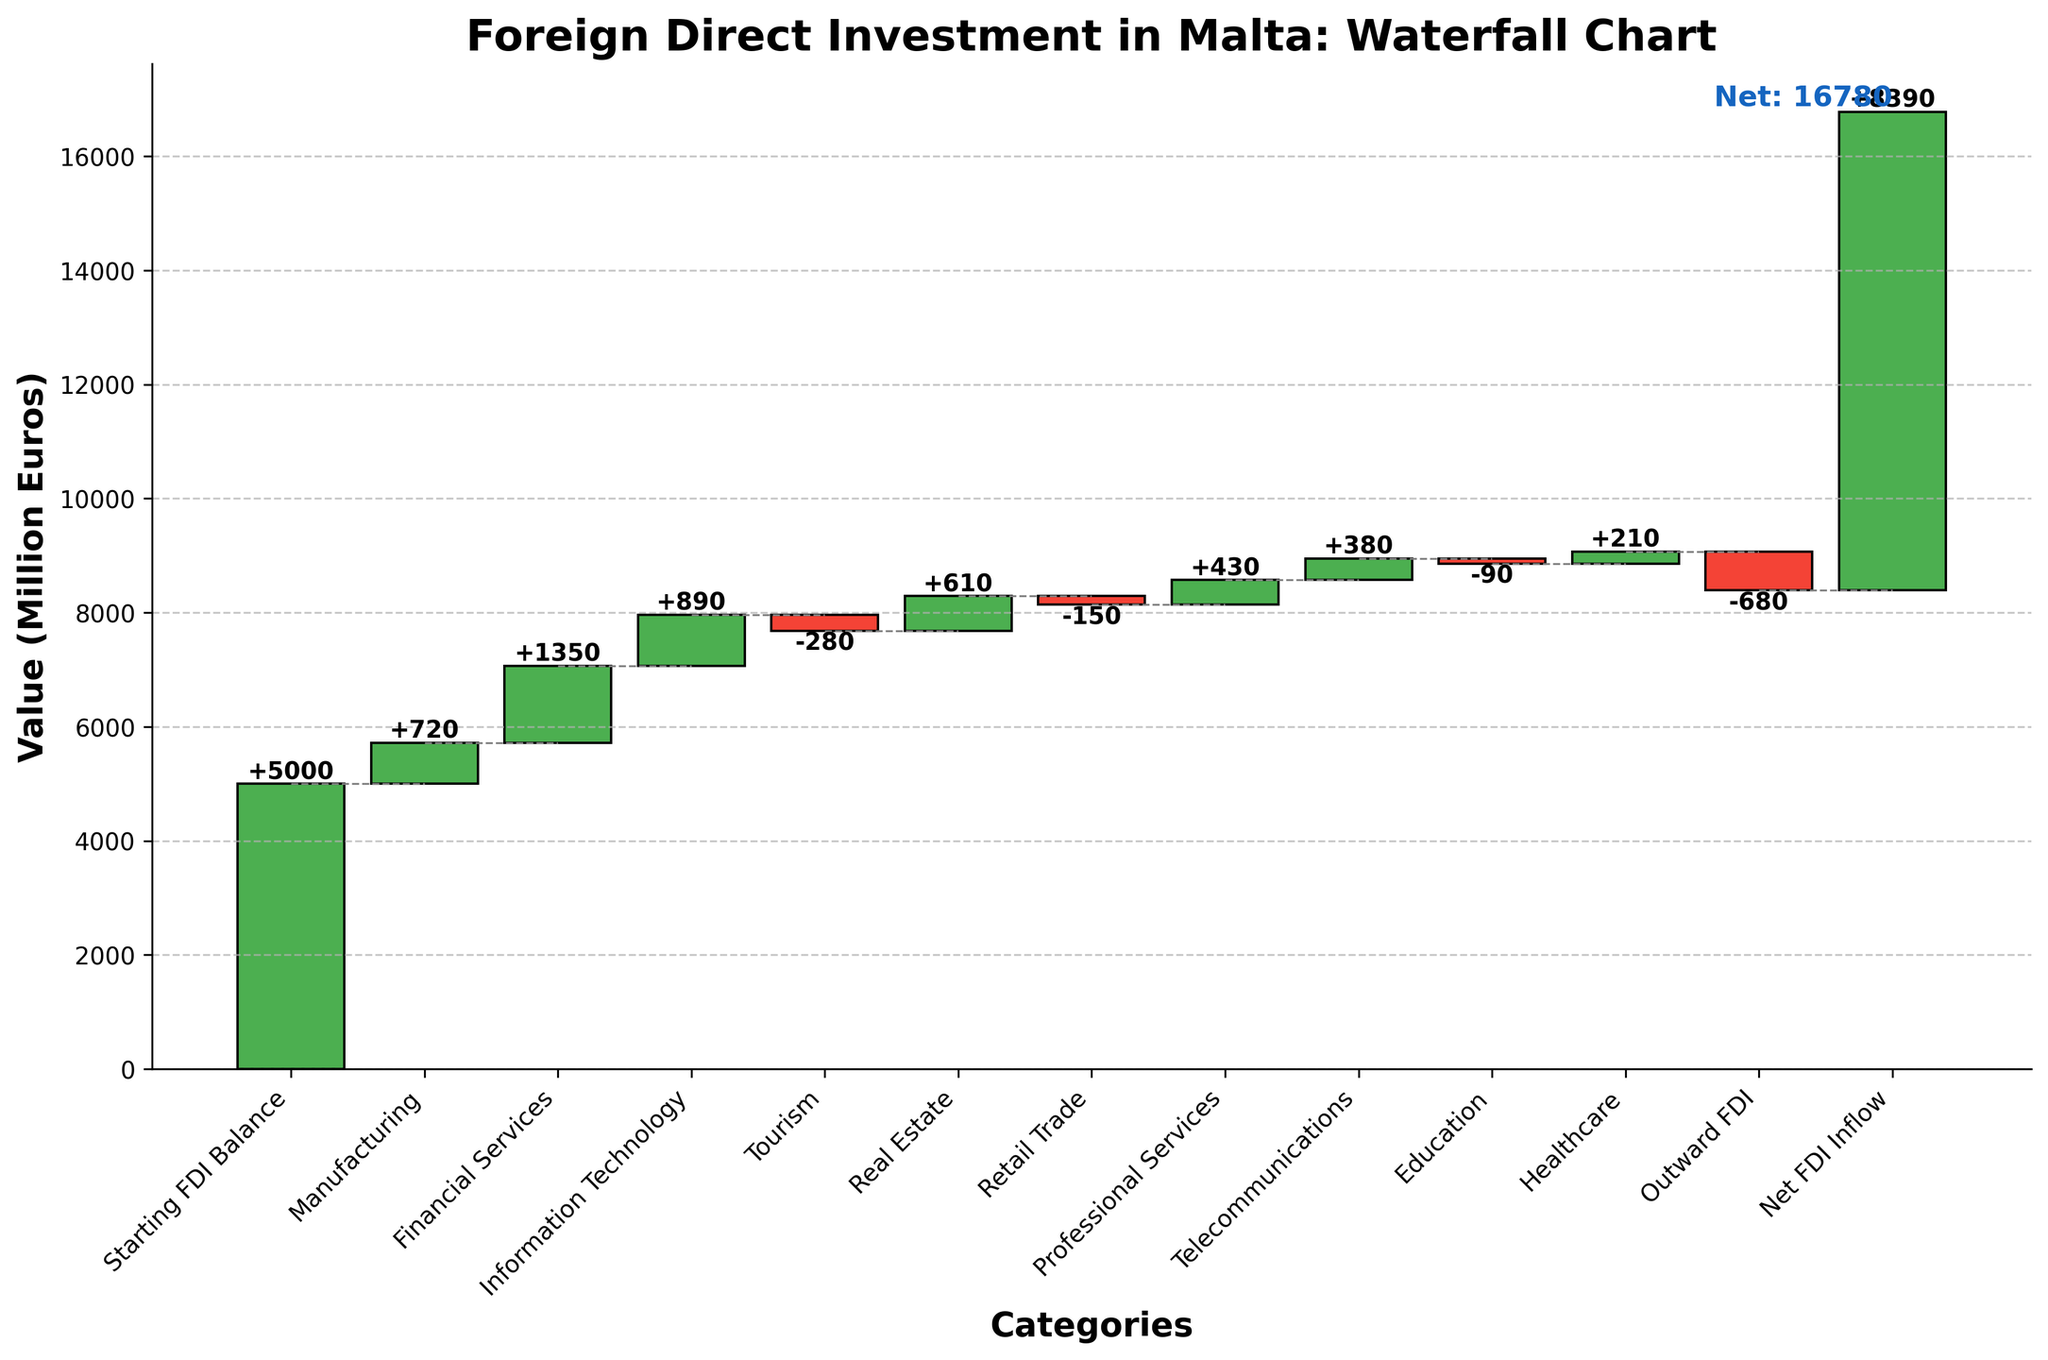What is the title of the chart? The title of the chart is found at the top and provides an overview of the chart's subject matter. In this case, it is "Foreign Direct Investment in Malta: Waterfall Chart".
Answer: Foreign Direct Investment in Malta: Waterfall Chart What is the value of the Starting FDI Balance? The value for "Starting FDI Balance" is the first bar shown in the chart, which is 5000 million euros.
Answer: 5000 How many sectors have positive FDI values? Count the number of bars that are colored green, as they represent positive FDI values.
Answer: 7 Which sector has the largest negative impact on FDI? Identify the sector with the largest red bar (negative value). The Tourism sector has the most extended red bar with a value of -280 million euros.
Answer: Tourism What is the difference in FDI values between Financial Services and Retail Trade? Subtract the FDI value of Retail Trade from the FDI value of Financial Services: 1350 - (-150) = 1500 million euros.
Answer: 1500 What is the cumulative FDI value after including the Healthcare sector? The cumulative value is calculated by sequentially adding each sector's FDI values. Starting with 5000, continuously add each sector until Healthcare: 5000 + 720 + 1350 + 890 - 280 + 610 - 150 + 430 + 380 - 90 + 210 = 9070 million euros.
Answer: 9070 Which has a higher cumulative impact on FDI, Information Technology or Real Estate? The cumulative FDI after Information Technology is higher than the cumulative FDI after Real Estate: after Information Technology it is 5000 + 720 + 1350 + 890 = 7960. After Real Estate it is 5000 + 720 + 1350 + 890 - 280 + 610 = 8290.
Answer: Real Estate By how much does Professional Services increase the FDI balance from the previous sector? Subtract the cumulative FDI value before Professional Services from the value after adding Professional Services: 8290 + 430 = 8720. Then calculate 8720 - 8290 = 430 million euros.
Answer: 430 What is the Net FDI Inflow value? The Net FDI Inflow is the last bar labeled in the chart, representing the final cumulative sum of all inflows and outflows. It is shown as 8390 million euros.
Answer: 8390 Which sector follows Financial Services in the chart? Locate Financial Services on the x-axis and identify the next category. The sector following Financial Services is Information Technology.
Answer: Information Technology 